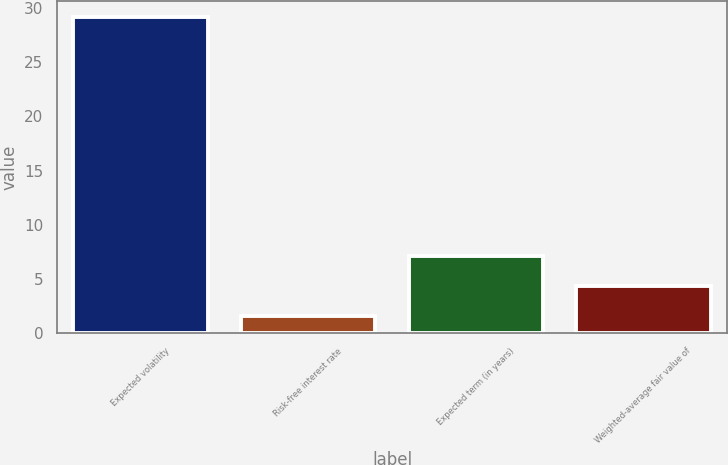<chart> <loc_0><loc_0><loc_500><loc_500><bar_chart><fcel>Expected volatility<fcel>Risk-free interest rate<fcel>Expected term (in years)<fcel>Weighted-average fair value of<nl><fcel>29.2<fcel>1.59<fcel>7.11<fcel>4.35<nl></chart> 